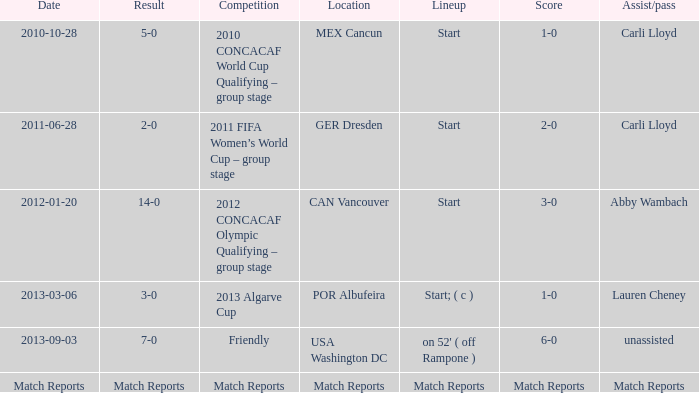Which score has a location of mex cancun? 1-0. 